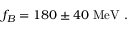Convert formula to latex. <formula><loc_0><loc_0><loc_500><loc_500>f _ { B } = 1 8 0 \pm 4 0 \ M e V \ .</formula> 